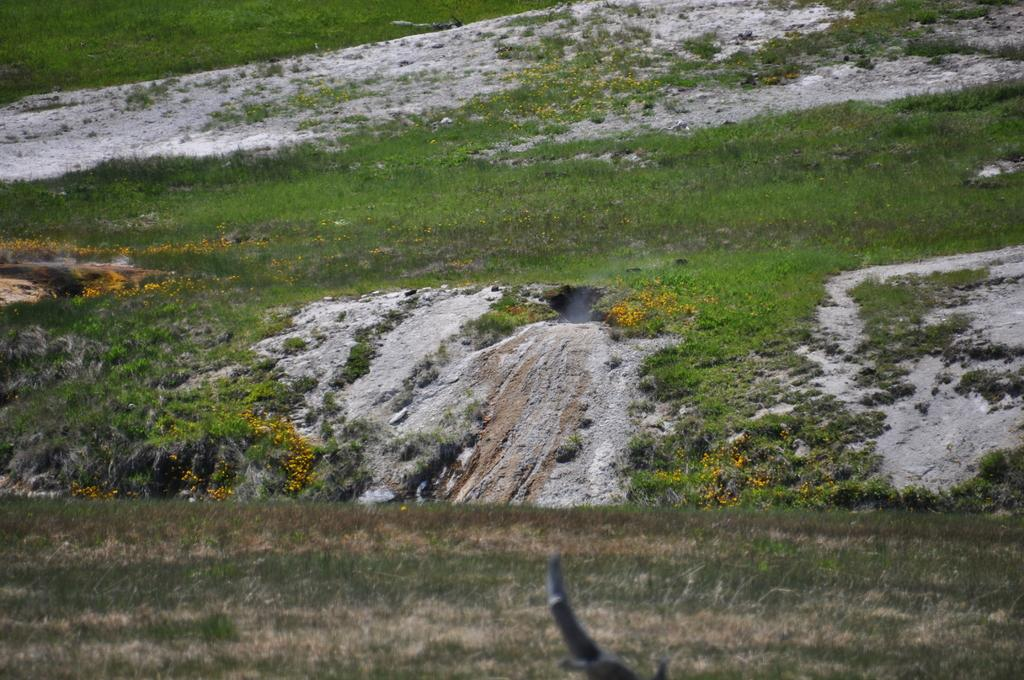What type of vegetation is present on the hill in the image? There is grass on the hill in the image. What can be seen in the background of the image? In the background, there are plants with flowers and dry lands. What type of vegetation is present on the ground in the image? There is grass on the ground in the image. What type of card is being used to water the plants in the image? There is no card present in the image, and no watering is taking place. 